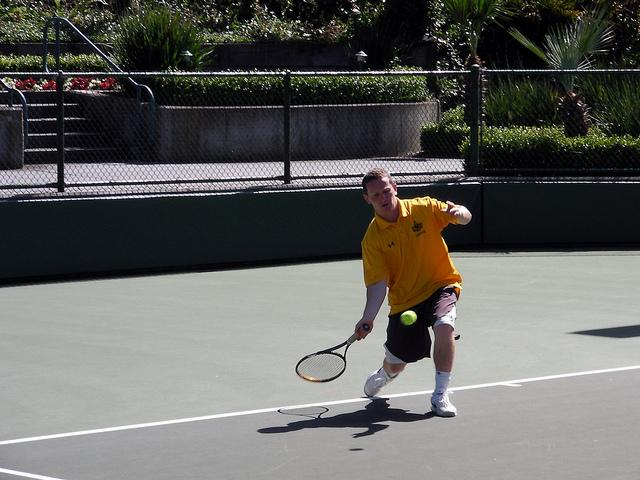What is the man attempting to do with the ball? hit 